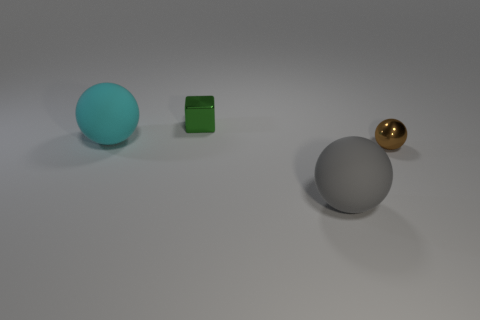Can you describe the lighting and shadows seen in the scene? The lighting in the scene is diffused and soft, suggesting an overcast or evenly lit environment. Shadows are present but not sharply defined, extending to the right side of the objects, which indicates the light source is coming from the left. The softness of the shadows suggests the light is not direct and may be reflecting off other surfaces. 